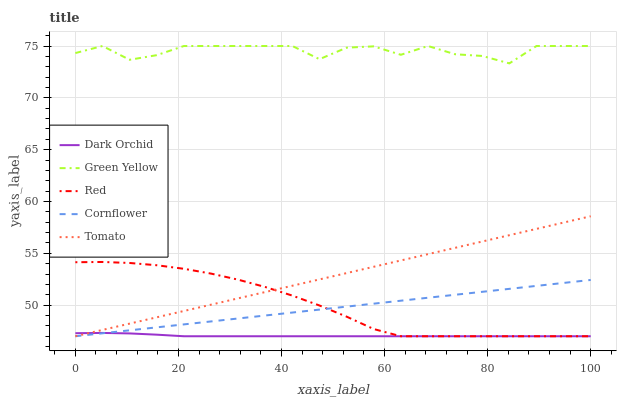Does Dark Orchid have the minimum area under the curve?
Answer yes or no. Yes. Does Green Yellow have the maximum area under the curve?
Answer yes or no. Yes. Does Cornflower have the minimum area under the curve?
Answer yes or no. No. Does Cornflower have the maximum area under the curve?
Answer yes or no. No. Is Tomato the smoothest?
Answer yes or no. Yes. Is Green Yellow the roughest?
Answer yes or no. Yes. Is Cornflower the smoothest?
Answer yes or no. No. Is Cornflower the roughest?
Answer yes or no. No. Does Green Yellow have the lowest value?
Answer yes or no. No. Does Green Yellow have the highest value?
Answer yes or no. Yes. Does Cornflower have the highest value?
Answer yes or no. No. Is Dark Orchid less than Green Yellow?
Answer yes or no. Yes. Is Green Yellow greater than Cornflower?
Answer yes or no. Yes. Does Dark Orchid intersect Green Yellow?
Answer yes or no. No. 